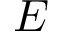Convert formula to latex. <formula><loc_0><loc_0><loc_500><loc_500>E</formula> 